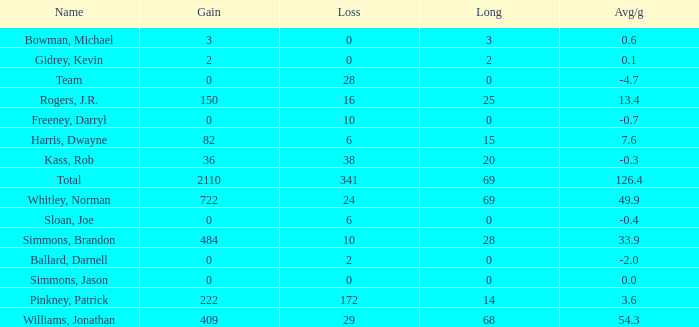Would you mind parsing the complete table? {'header': ['Name', 'Gain', 'Loss', 'Long', 'Avg/g'], 'rows': [['Bowman, Michael', '3', '0', '3', '0.6'], ['Gidrey, Kevin', '2', '0', '2', '0.1'], ['Team', '0', '28', '0', '-4.7'], ['Rogers, J.R.', '150', '16', '25', '13.4'], ['Freeney, Darryl', '0', '10', '0', '-0.7'], ['Harris, Dwayne', '82', '6', '15', '7.6'], ['Kass, Rob', '36', '38', '20', '-0.3'], ['Total', '2110', '341', '69', '126.4'], ['Whitley, Norman', '722', '24', '69', '49.9'], ['Sloan, Joe', '0', '6', '0', '-0.4'], ['Simmons, Brandon', '484', '10', '28', '33.9'], ['Ballard, Darnell', '0', '2', '0', '-2.0'], ['Simmons, Jason', '0', '0', '0', '0.0'], ['Pinkney, Patrick', '222', '172', '14', '3.6'], ['Williams, Jonathan', '409', '29', '68', '54.3']]} What is the lowest Loss, when Long is less than 0? None. 